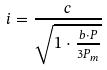Convert formula to latex. <formula><loc_0><loc_0><loc_500><loc_500>i = \frac { c } { \sqrt { 1 \cdot \frac { b \cdot P } { 3 P _ { m } } } }</formula> 